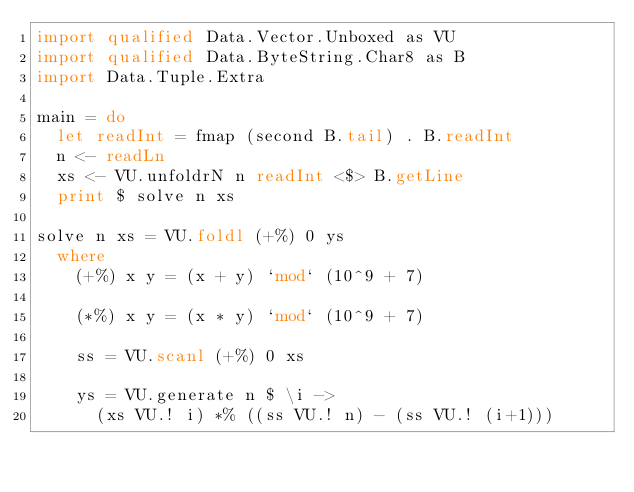<code> <loc_0><loc_0><loc_500><loc_500><_Haskell_>import qualified Data.Vector.Unboxed as VU
import qualified Data.ByteString.Char8 as B
import Data.Tuple.Extra

main = do
  let readInt = fmap (second B.tail) . B.readInt
  n <- readLn
  xs <- VU.unfoldrN n readInt <$> B.getLine
  print $ solve n xs

solve n xs = VU.foldl (+%) 0 ys
  where
    (+%) x y = (x + y) `mod` (10^9 + 7)

    (*%) x y = (x * y) `mod` (10^9 + 7)

    ss = VU.scanl (+%) 0 xs

    ys = VU.generate n $ \i ->
      (xs VU.! i) *% ((ss VU.! n) - (ss VU.! (i+1)))
</code> 